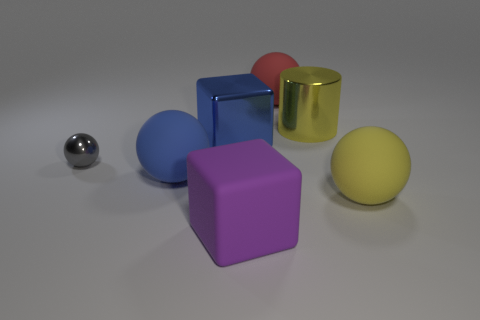Add 2 large yellow things. How many objects exist? 9 Subtract all balls. How many objects are left? 3 Subtract all large red matte things. Subtract all big red balls. How many objects are left? 5 Add 7 big purple blocks. How many big purple blocks are left? 8 Add 7 cylinders. How many cylinders exist? 8 Subtract 0 gray cylinders. How many objects are left? 7 